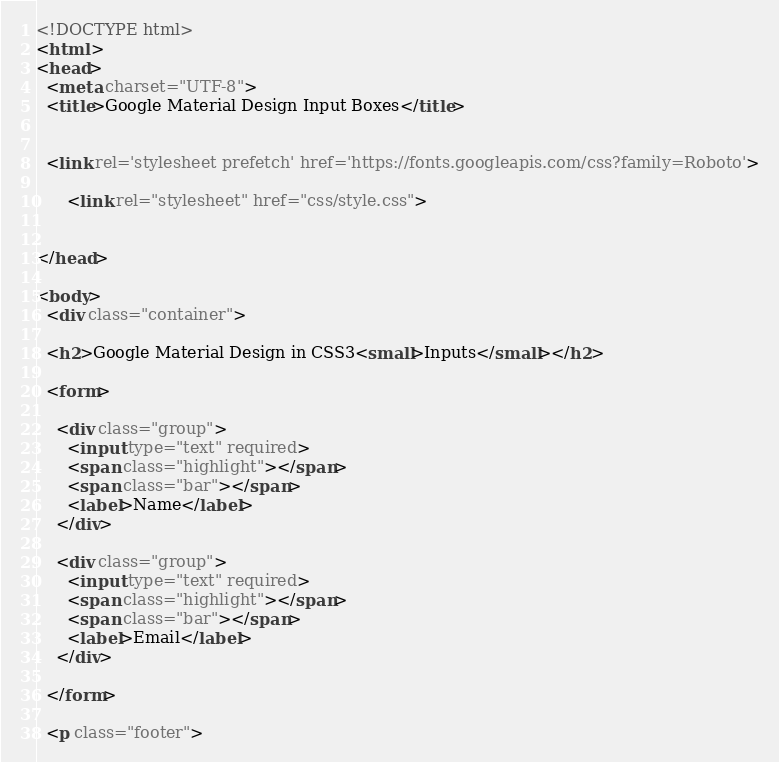Convert code to text. <code><loc_0><loc_0><loc_500><loc_500><_HTML_><!DOCTYPE html>
<html >
<head>
  <meta charset="UTF-8">
  <title>Google Material Design Input Boxes</title>
  
  
  <link rel='stylesheet prefetch' href='https://fonts.googleapis.com/css?family=Roboto'>

      <link rel="stylesheet" href="css/style.css">

  
</head>

<body>
  <div class="container">
  
  <h2>Google Material Design in CSS3<small>Inputs</small></h2>
  
  <form>
    
    <div class="group">      
      <input type="text" required>
      <span class="highlight"></span>
      <span class="bar"></span>
      <label>Name</label>
    </div>
      
    <div class="group">      
      <input type="text" required>
      <span class="highlight"></span>
      <span class="bar"></span>
      <label>Email</label>
    </div>
    
  </form>
      
  <p class="footer"></code> 